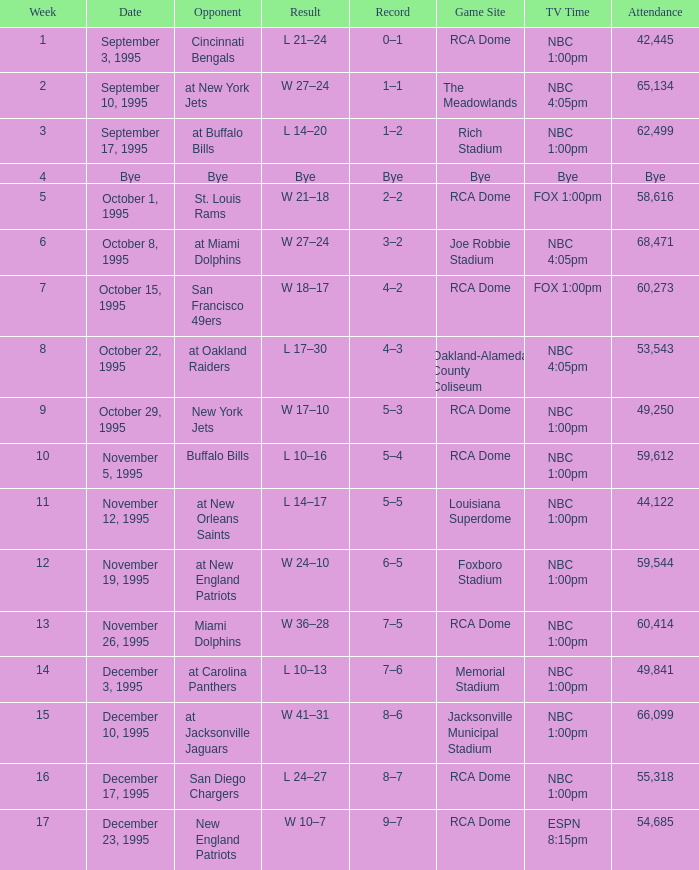What's the Game SIte with an Opponent of San Diego Chargers? RCA Dome. 